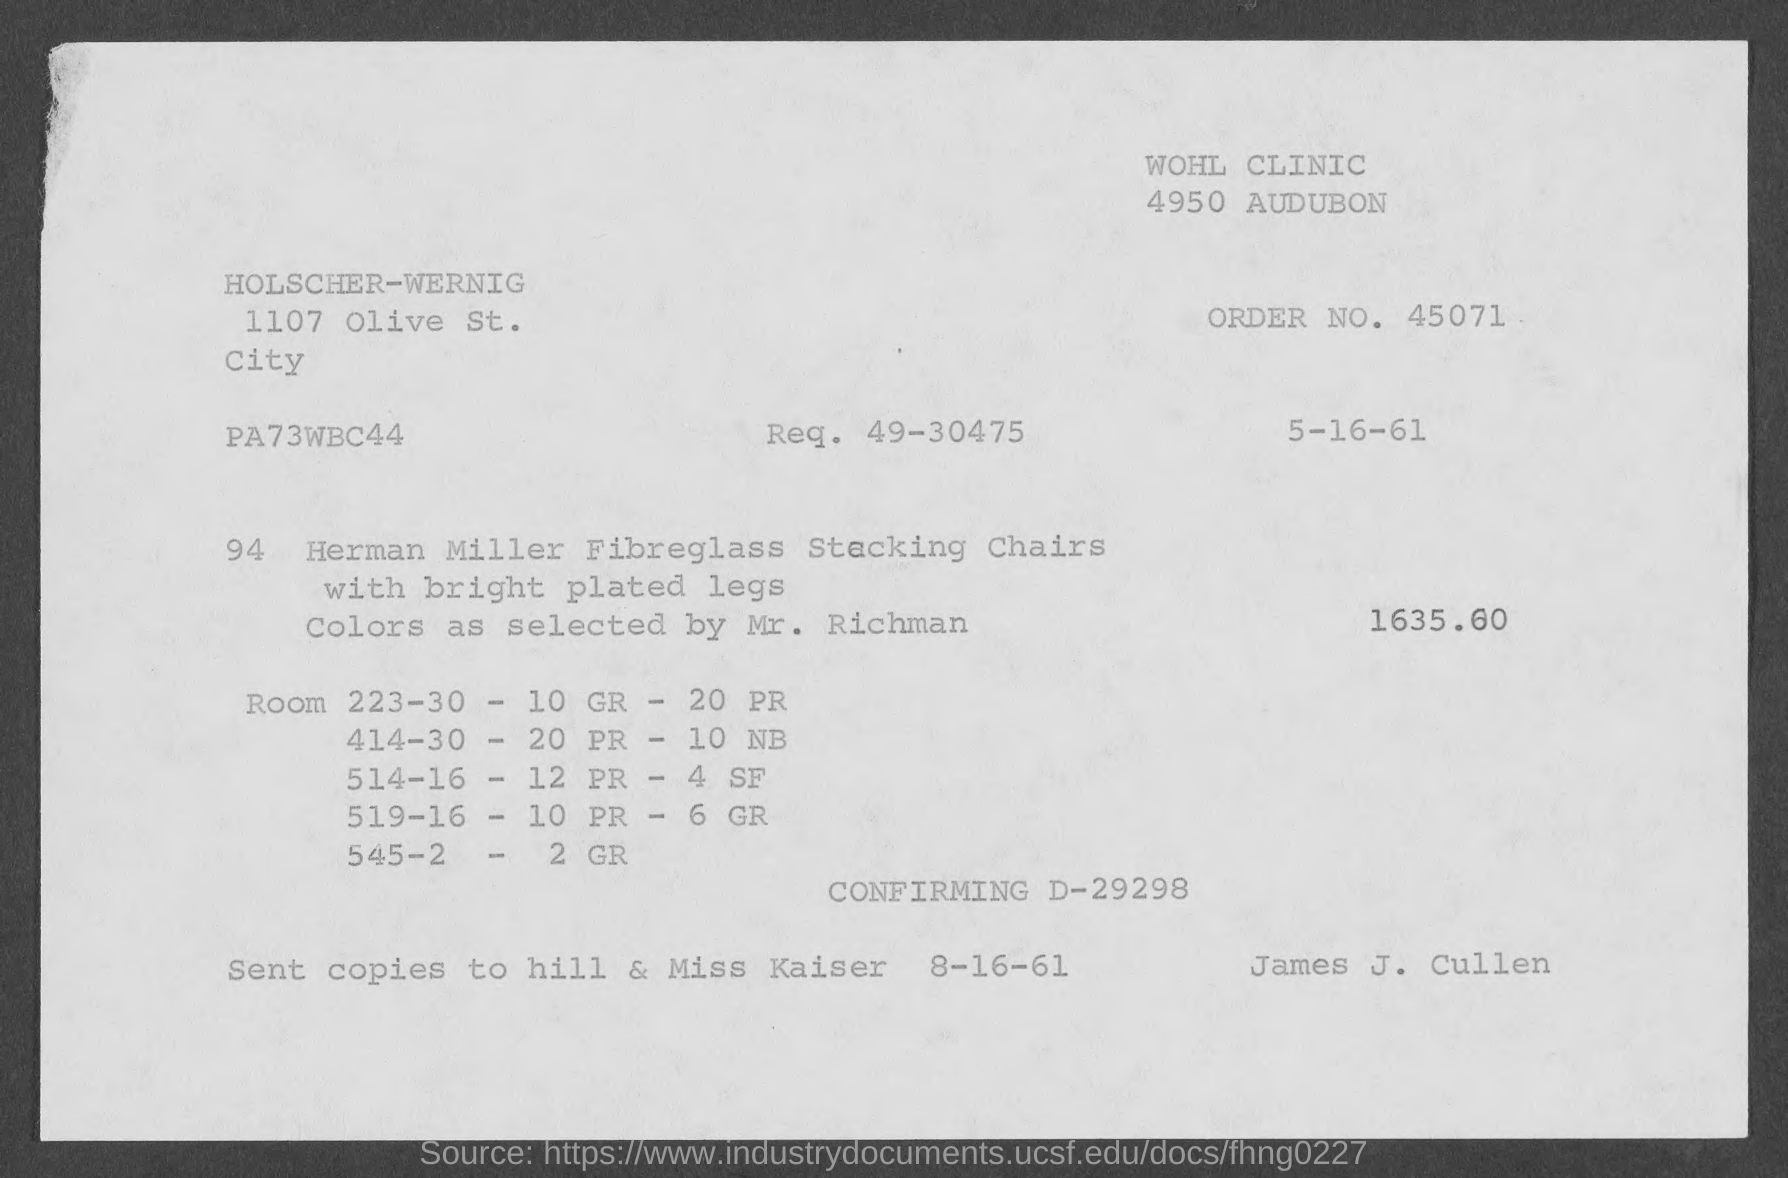Point out several critical features in this image. I am unable to complete the task. "what is the order no. mentioned in the given page ? 45071.." is a question that requires additional context and information in order to provide a meaningful response. The request mentioned in the given form is 49-30475. The amount mentioned in the given form is 1635.60... 